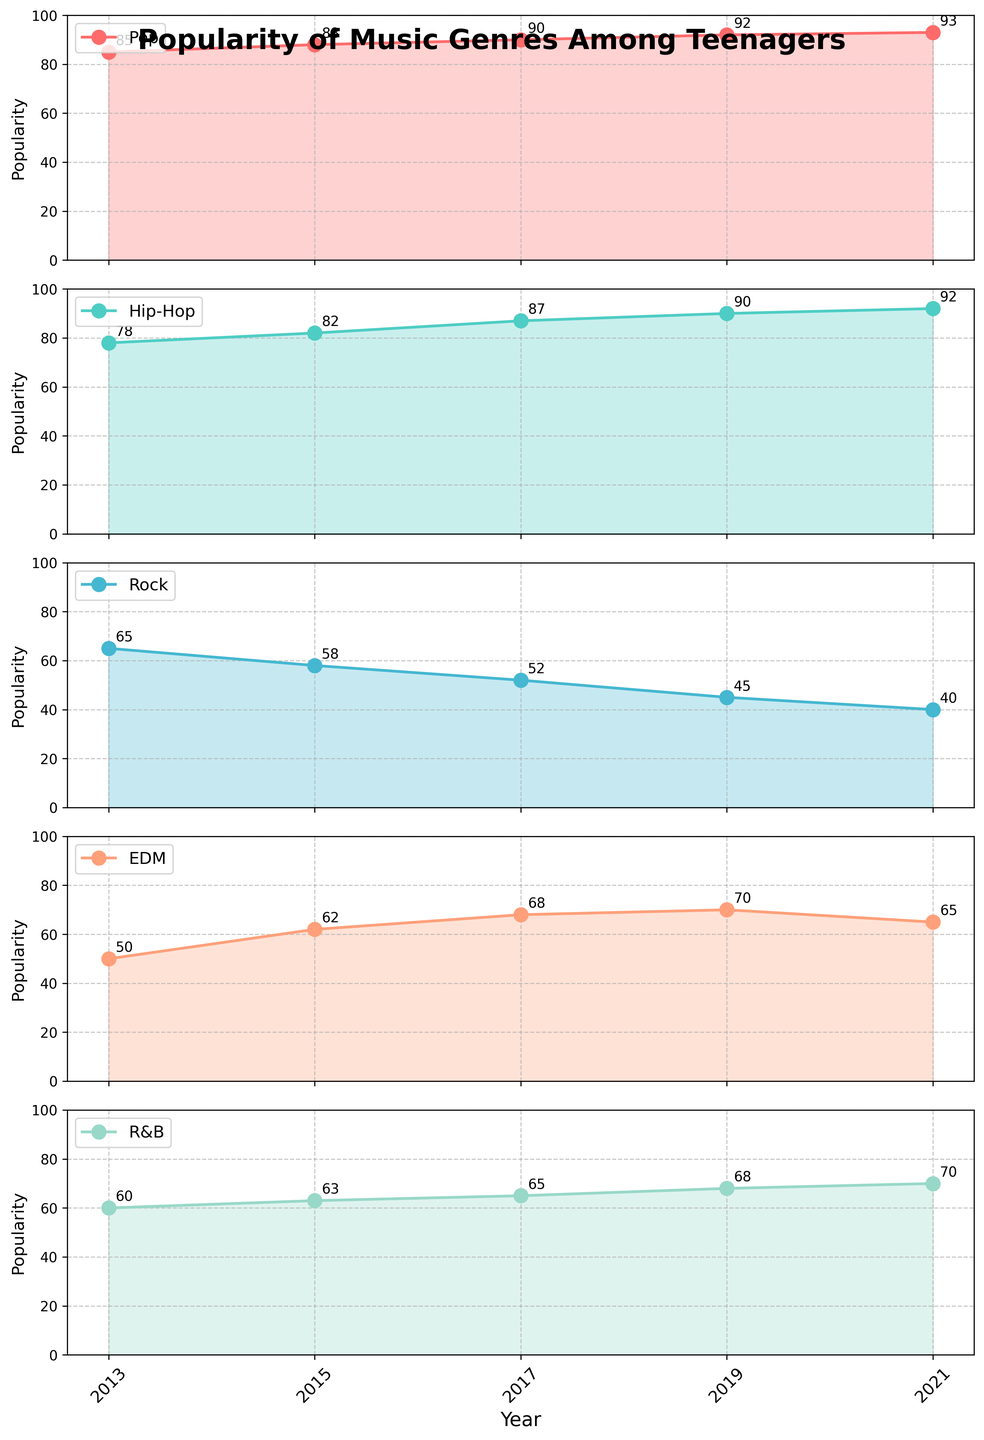What is the title of the figure? The title is located at the top of the figure, and it provides a brief summary of what the figure represents.
Answer: Popularity of Music Genres Among Teenagers What is the y-axis label for each subplot? The y-axis label can be found along the left side of each subplot and it indicates what is being measured in the plot.
Answer: Popularity In which year did Pop music achieve its highest popularity? By looking at the data points for Pop across the years, the highest value is 93 in the year 2021.
Answer: 2021 Between which years did Hip-Hop music see the largest increase in popularity? By comparing the popularity values of Hip-Hop over the years, the largest increase is between 2013 (78) and 2015 (82), an increase of 4 points.
Answer: 2013 and 2015 Which genre saw a decrease in popularity from 2017 to 2019? Looking at the plots for each genre, only Rock music shows a decrease in popularity from 52 (in 2017) to 45 (in 2019).
Answer: Rock What is the average popularity of EDM across all years? To find the average, sum the popularity values for EDM (50, 62, 68, 70, 65) and divide by the number of years (5). The sum is 315, so the average is 315 / 5 = 63.
Answer: 63 Which genre was consistently more popular than Rock every year? Comparing each year, Hip-Hop (78, 82, 87, 90, 92), Pop (85, 88, 90, 92, 93), and R&B (60, 63, 65, 68, 70) were all consistently more popular than Rock in every year.
Answer: Hip-Hop, Pop, R&B How much more popular was Rock in 2013 compared to 2021? Subtract the popularity of Rock in 2021 (40) from its popularity in 2013 (65), which results in a difference of 25.
Answer: 25 Did any genre have a constant increase in popularity from 2013 to 2021? Observing the trend for each genre, both Hip-Hop and Pop show a consistent increase in popularity over all the years.
Answer: Hip-Hop, Pop Which genre had the least popular year in 2019? Looking at all the genre subplots, Rock had the least popularity in 2019 with a value of 45.
Answer: Rock 